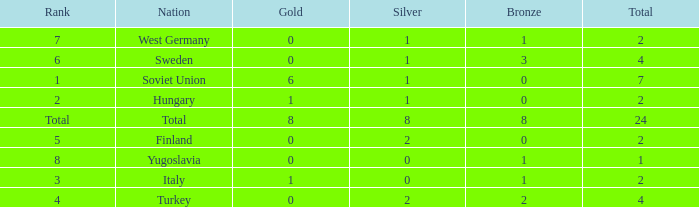What would be the lowest bronze if gold is less than 0? None. 